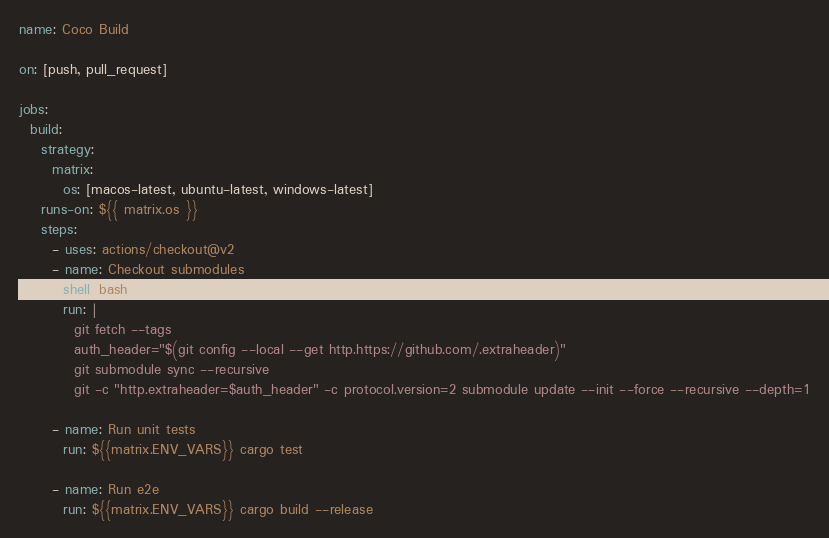<code> <loc_0><loc_0><loc_500><loc_500><_YAML_>name: Coco Build

on: [push, pull_request]

jobs:
  build:
    strategy:
      matrix:
        os: [macos-latest, ubuntu-latest, windows-latest]
    runs-on: ${{ matrix.os }}
    steps:
      - uses: actions/checkout@v2
      - name: Checkout submodules
        shell: bash
        run: |
          git fetch --tags
          auth_header="$(git config --local --get http.https://github.com/.extraheader)"
          git submodule sync --recursive
          git -c "http.extraheader=$auth_header" -c protocol.version=2 submodule update --init --force --recursive --depth=1

      - name: Run unit tests
        run: ${{matrix.ENV_VARS}} cargo test

      - name: Run e2e
        run: ${{matrix.ENV_VARS}} cargo build --release
</code> 